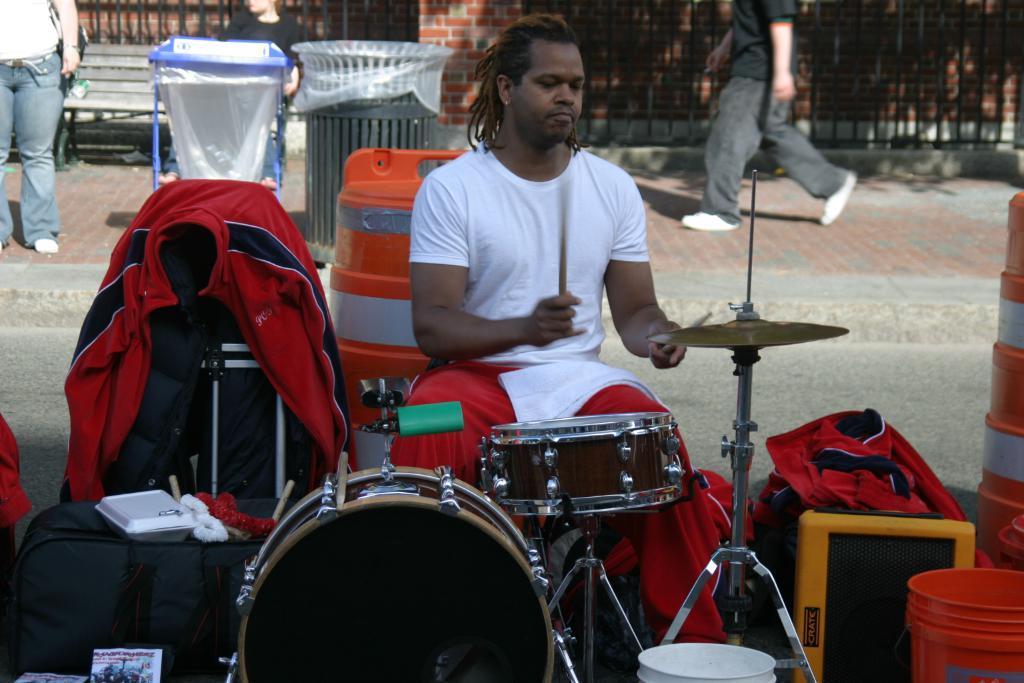Can you describe this image briefly? In the image in the center we can see one man sitting and he holding sticks in his hand. And in front of him we can see some musical instruments,jacket,luggage and bucket etc. And back of him we can see the brick wall and two persons were standing. And one person he is walking. And we can see few objects around them. 